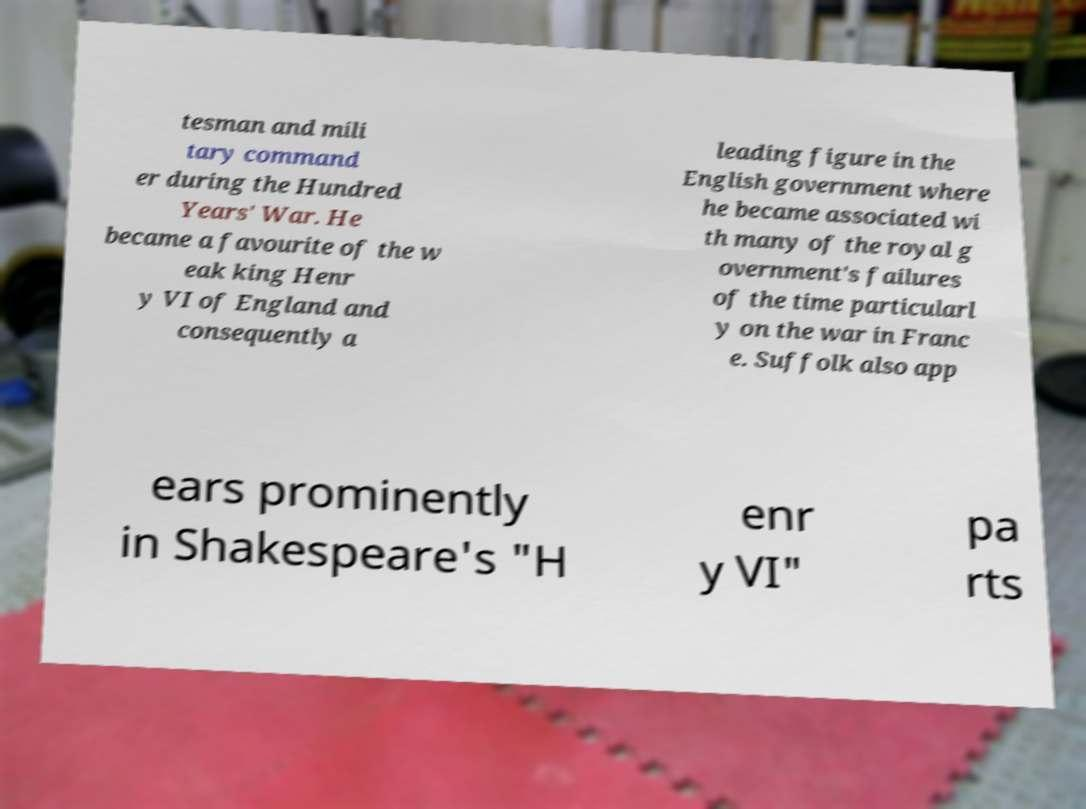What messages or text are displayed in this image? I need them in a readable, typed format. tesman and mili tary command er during the Hundred Years' War. He became a favourite of the w eak king Henr y VI of England and consequently a leading figure in the English government where he became associated wi th many of the royal g overnment's failures of the time particularl y on the war in Franc e. Suffolk also app ears prominently in Shakespeare's "H enr y VI" pa rts 